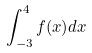Convert formula to latex. <formula><loc_0><loc_0><loc_500><loc_500>\int _ { - 3 } ^ { 4 } f ( x ) d x</formula> 